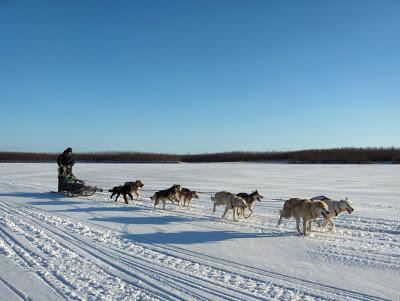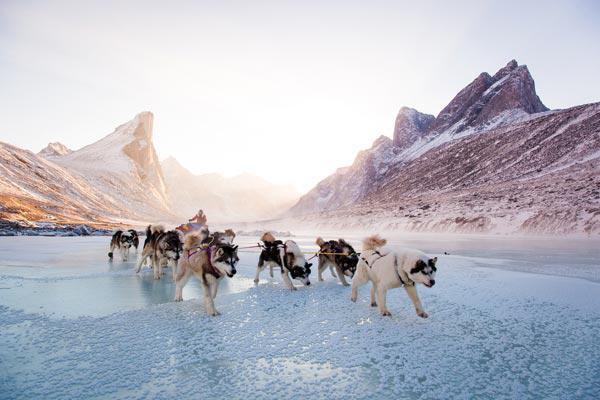The first image is the image on the left, the second image is the image on the right. Examine the images to the left and right. Is the description "There is at most 2 groups of sleigh dogs pulling a sled to the left in the snow." accurate? Answer yes or no. No. The first image is the image on the left, the second image is the image on the right. Assess this claim about the two images: "In the left image, there's a single team of sled dogs running across the snow to the lower right.". Correct or not? Answer yes or no. Yes. 